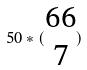<formula> <loc_0><loc_0><loc_500><loc_500>5 0 * ( \begin{matrix} 6 6 \\ 7 \end{matrix} )</formula> 